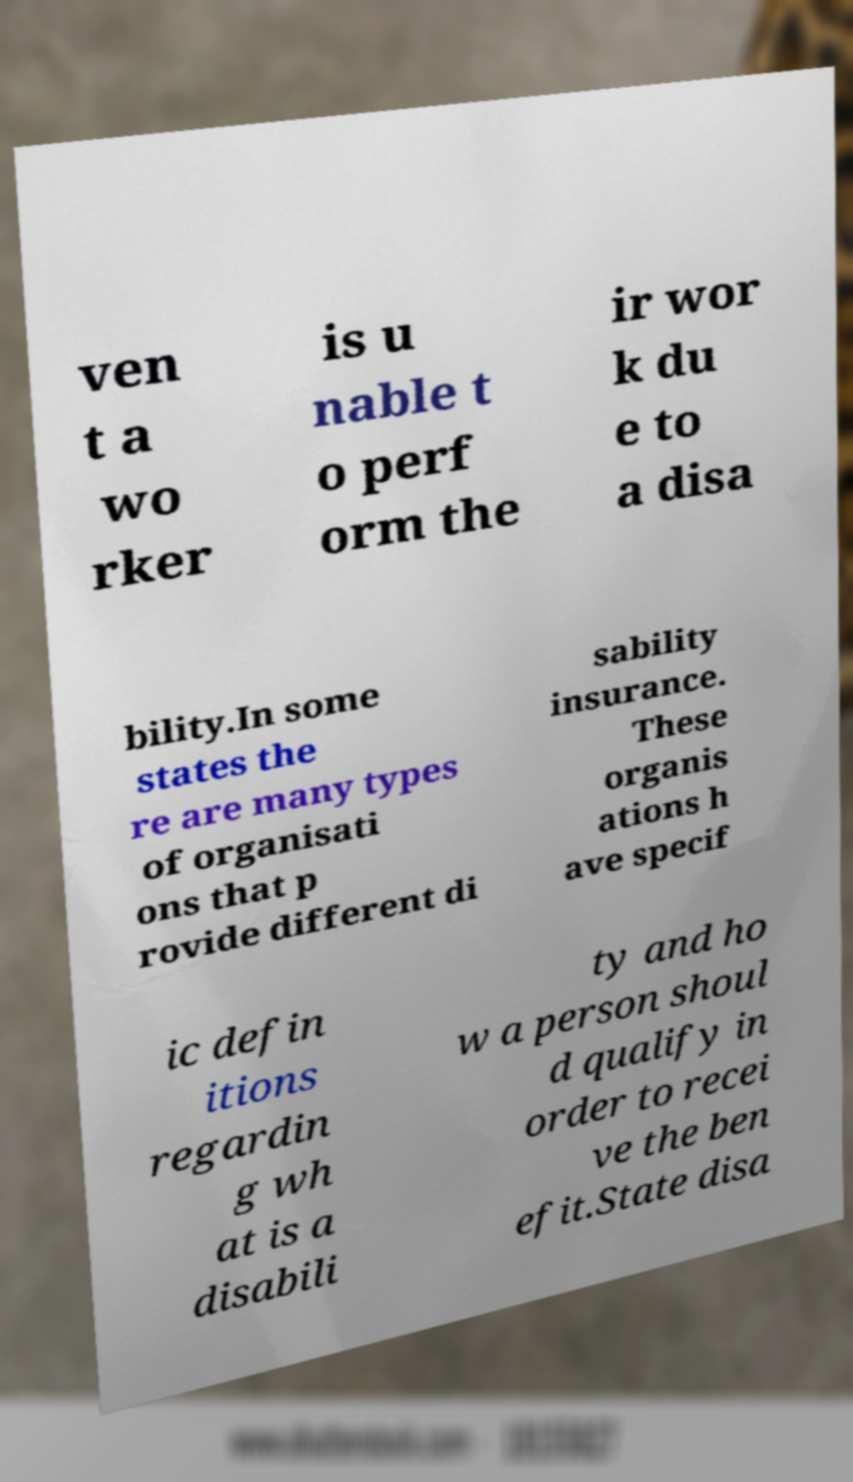Could you assist in decoding the text presented in this image and type it out clearly? ven t a wo rker is u nable t o perf orm the ir wor k du e to a disa bility.In some states the re are many types of organisati ons that p rovide different di sability insurance. These organis ations h ave specif ic defin itions regardin g wh at is a disabili ty and ho w a person shoul d qualify in order to recei ve the ben efit.State disa 